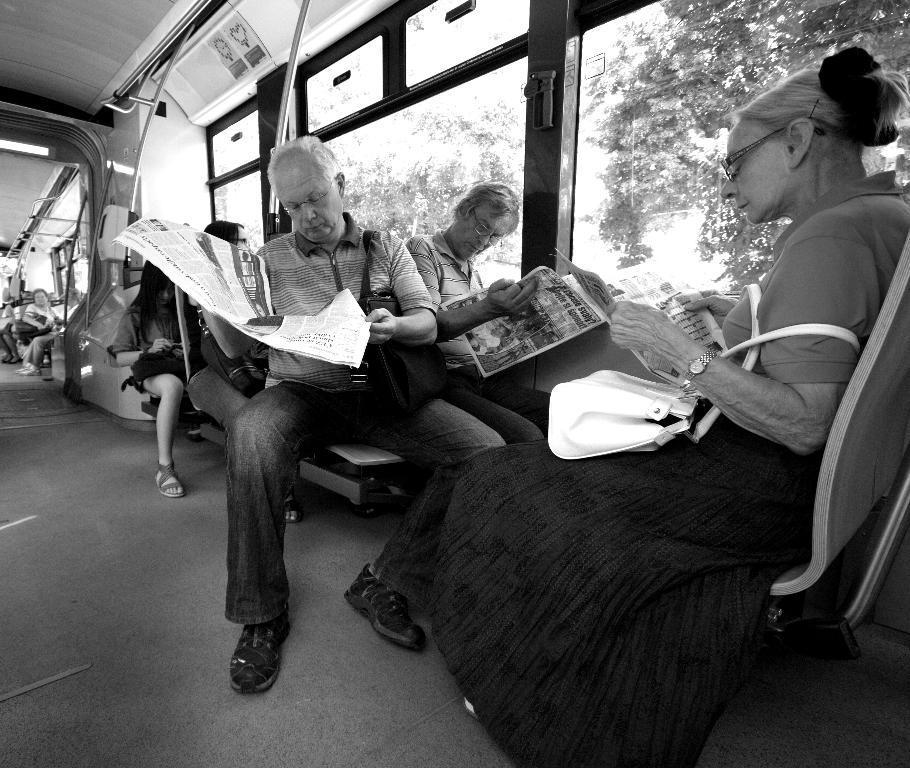Please provide a concise description of this image. In this image there are group of persons sitting inside the vehicle. In the front there are persons sitting and reading a newspaper and on the right side there are windows, behind the windows there are trees. 